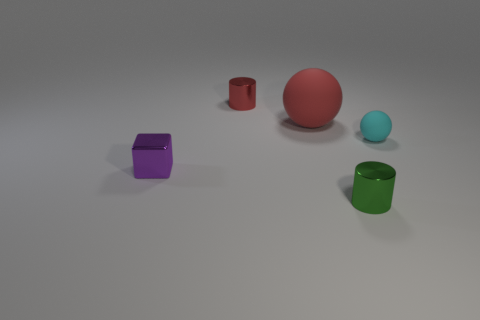Add 1 large red objects. How many objects exist? 6 Subtract all cubes. How many objects are left? 4 Subtract all tiny cyan spheres. Subtract all purple shiny things. How many objects are left? 3 Add 4 tiny purple shiny blocks. How many tiny purple shiny blocks are left? 5 Add 1 tiny cyan things. How many tiny cyan things exist? 2 Subtract 0 blue cubes. How many objects are left? 5 